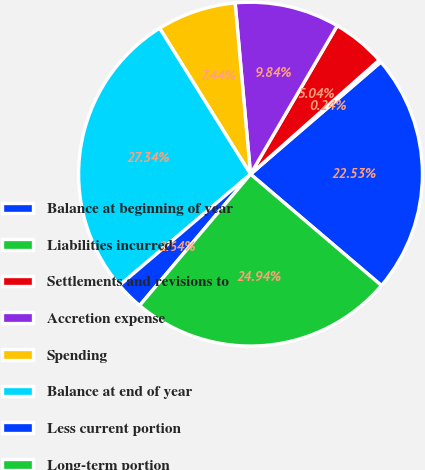Convert chart. <chart><loc_0><loc_0><loc_500><loc_500><pie_chart><fcel>Balance at beginning of year<fcel>Liabilities incurred<fcel>Settlements and revisions to<fcel>Accretion expense<fcel>Spending<fcel>Balance at end of year<fcel>Less current portion<fcel>Long-term portion<nl><fcel>22.53%<fcel>0.24%<fcel>5.04%<fcel>9.84%<fcel>7.44%<fcel>27.34%<fcel>2.64%<fcel>24.94%<nl></chart> 